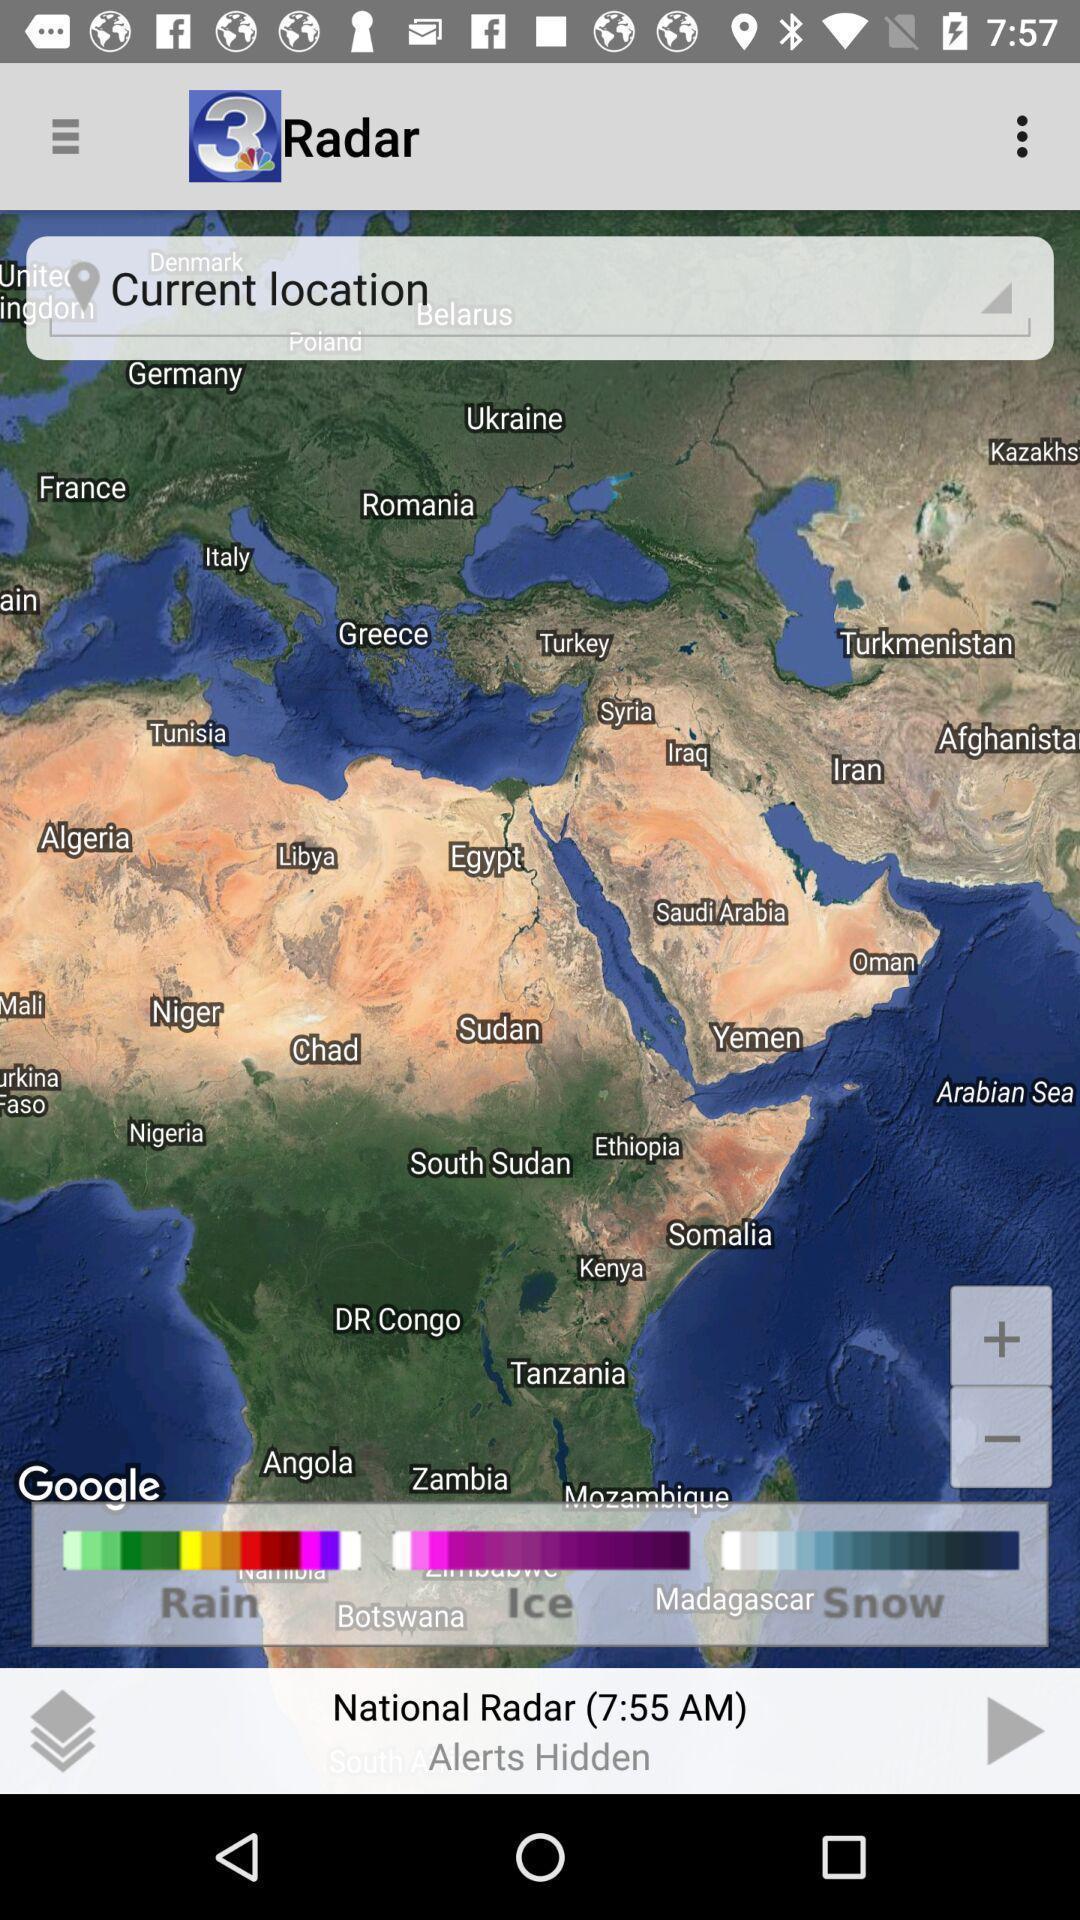Tell me what you see in this picture. Search page for locations in the weather app. 